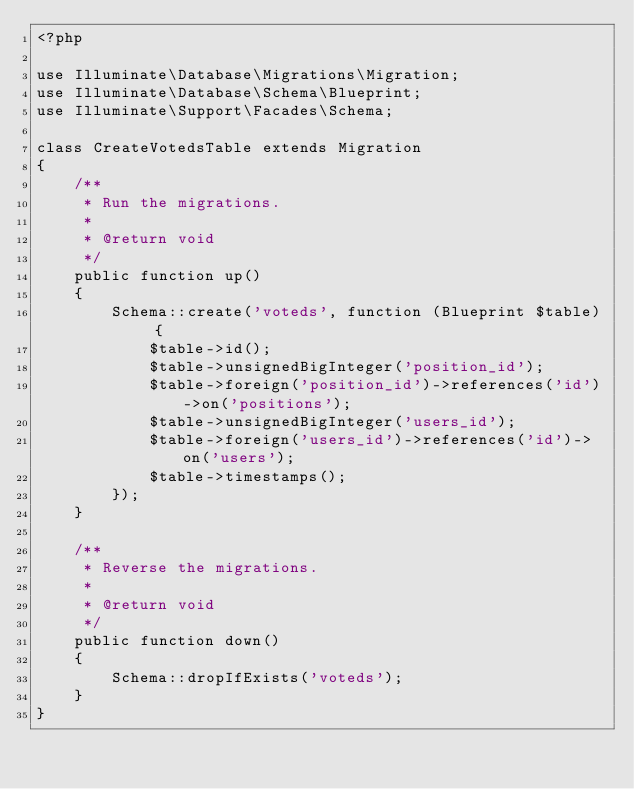Convert code to text. <code><loc_0><loc_0><loc_500><loc_500><_PHP_><?php

use Illuminate\Database\Migrations\Migration;
use Illuminate\Database\Schema\Blueprint;
use Illuminate\Support\Facades\Schema;

class CreateVotedsTable extends Migration
{
    /**
     * Run the migrations.
     *
     * @return void
     */
    public function up()
    {
        Schema::create('voteds', function (Blueprint $table) {
            $table->id();
            $table->unsignedBigInteger('position_id');
            $table->foreign('position_id')->references('id')->on('positions');
            $table->unsignedBigInteger('users_id');
            $table->foreign('users_id')->references('id')->on('users');
            $table->timestamps();
        });
    }

    /**
     * Reverse the migrations.
     *
     * @return void
     */
    public function down()
    {
        Schema::dropIfExists('voteds');
    }
}
</code> 